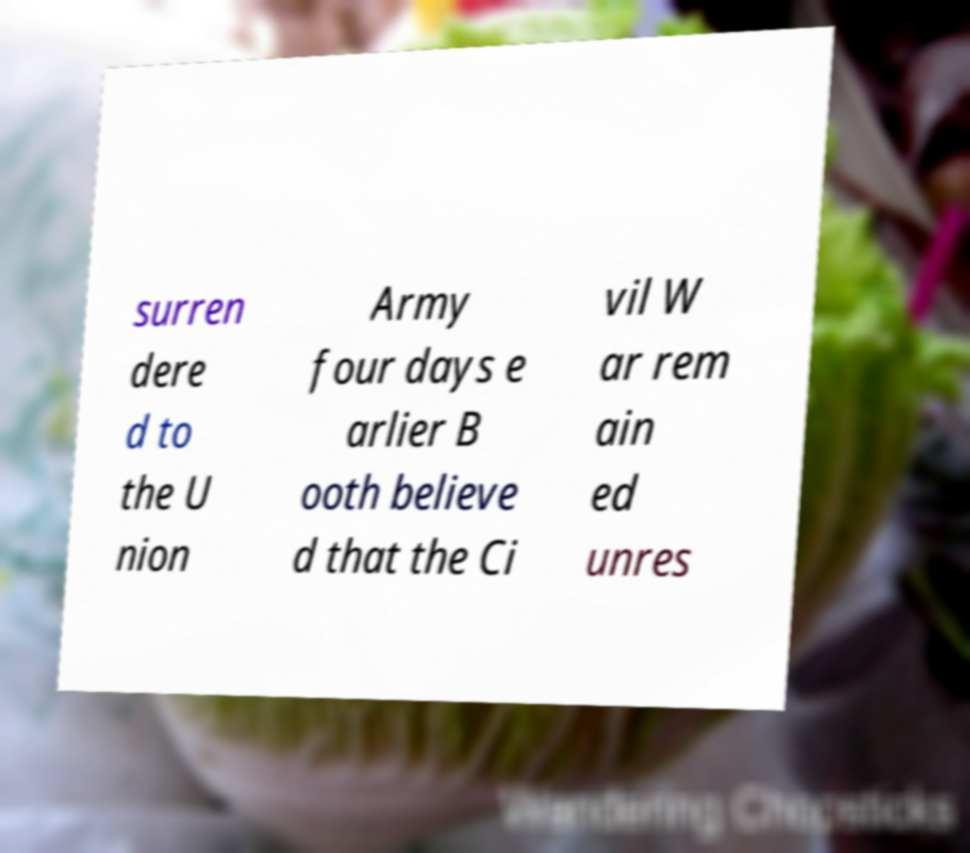There's text embedded in this image that I need extracted. Can you transcribe it verbatim? surren dere d to the U nion Army four days e arlier B ooth believe d that the Ci vil W ar rem ain ed unres 